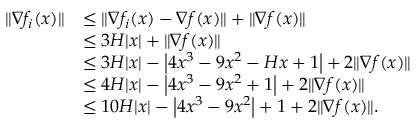<formula> <loc_0><loc_0><loc_500><loc_500>\begin{array} { r l } { \| \nabla f _ { i } ( x ) \| } & { \leq \| \nabla f _ { i } ( x ) - \nabla f ( x ) \| + \| \nabla f ( x ) \| } \\ & { \leq 3 H | x | + \| \nabla f ( x ) \| } \\ & { \leq 3 H | x | - \left | 4 x ^ { 3 } - 9 x ^ { 2 } - H x + 1 \right | + 2 \| \nabla f ( x ) \| } \\ & { \leq 4 H | x | - \left | 4 x ^ { 3 } - 9 x ^ { 2 } + 1 \right | + 2 \| \nabla f ( x ) \| } \\ & { \leq 1 0 H | x | - \left | 4 x ^ { 3 } - 9 x ^ { 2 } \right | + 1 + 2 \| \nabla f ( x ) \| . } \end{array}</formula> 